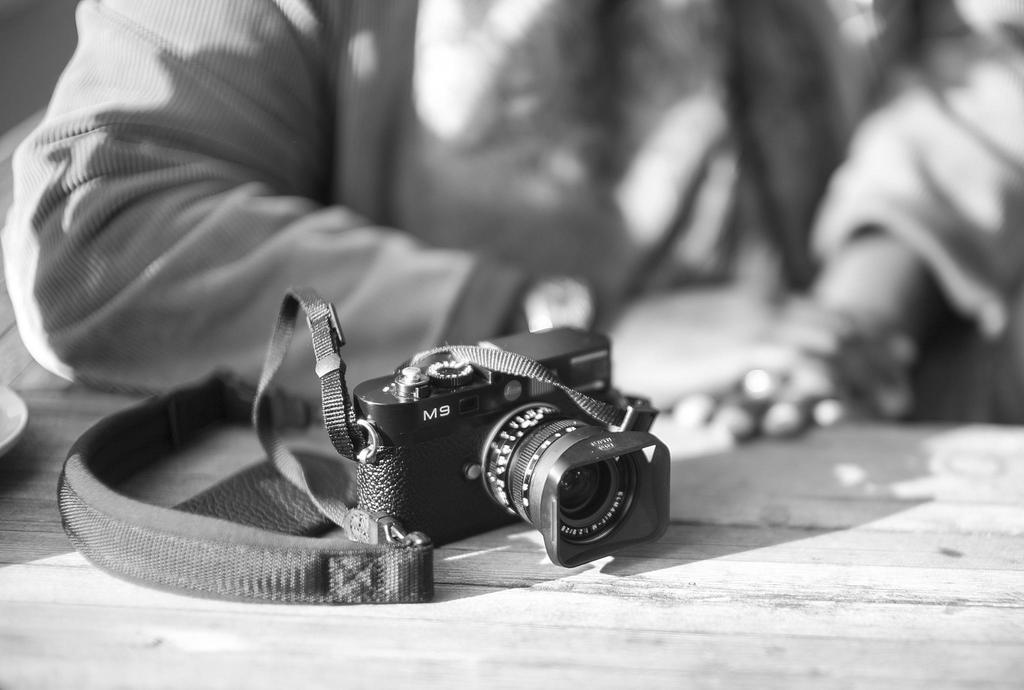<image>
Give a short and clear explanation of the subsequent image. A camera that says M9 is on a table a person is sitting at. 